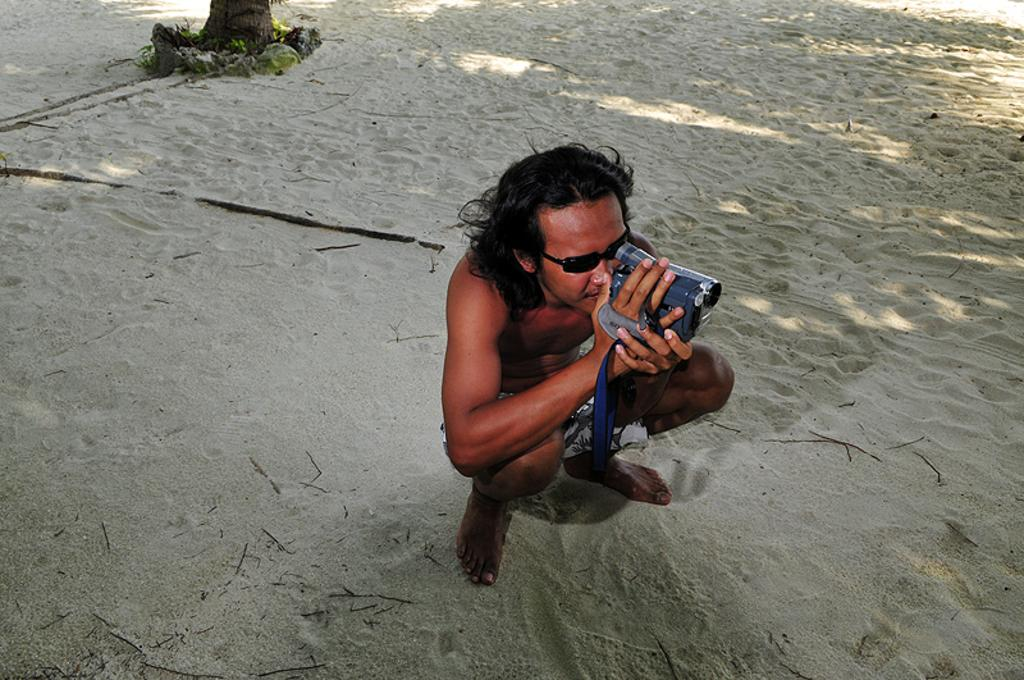What can be seen in the image? There is a person in the image. What is the person wearing? The person is wearing sunglasses. What is the person holding? The person is holding a camera. What type of surface is visible in the image? There is sand visible in the image. What type of secretary can be seen in the image? There is no secretary present in the image; it features a person holding a camera. 